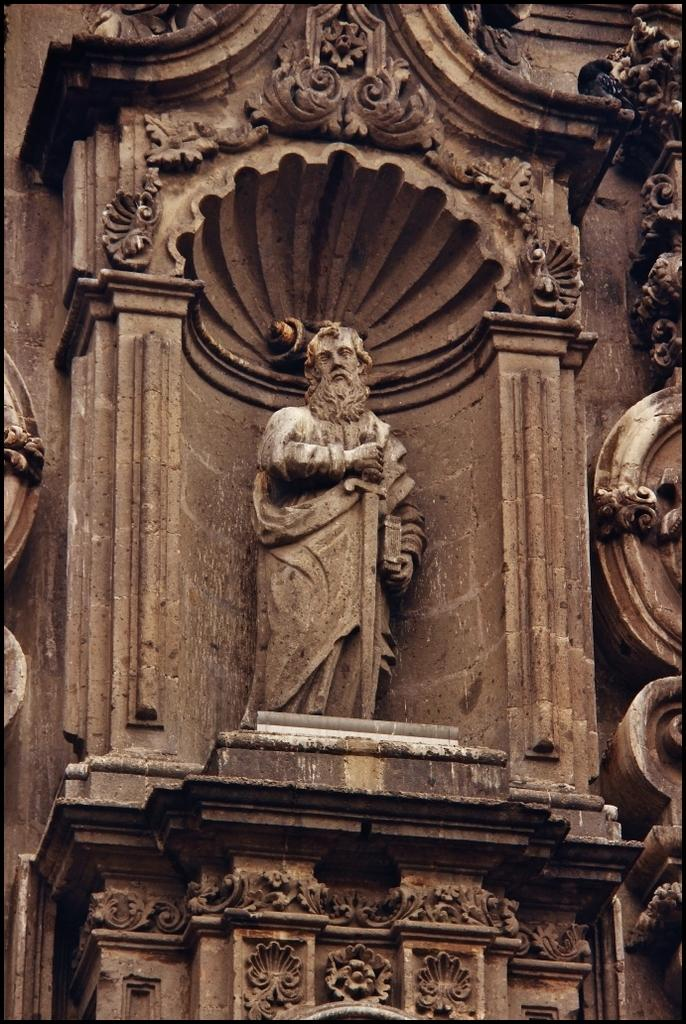What is the main subject of the image? There is a carved sculpture in the image. What can be seen on the wall in the image? There are designs on the wall in the image. What is the purpose of the lumber in the image? There is no lumber present in the image, so it cannot be determined what its purpose might be. 